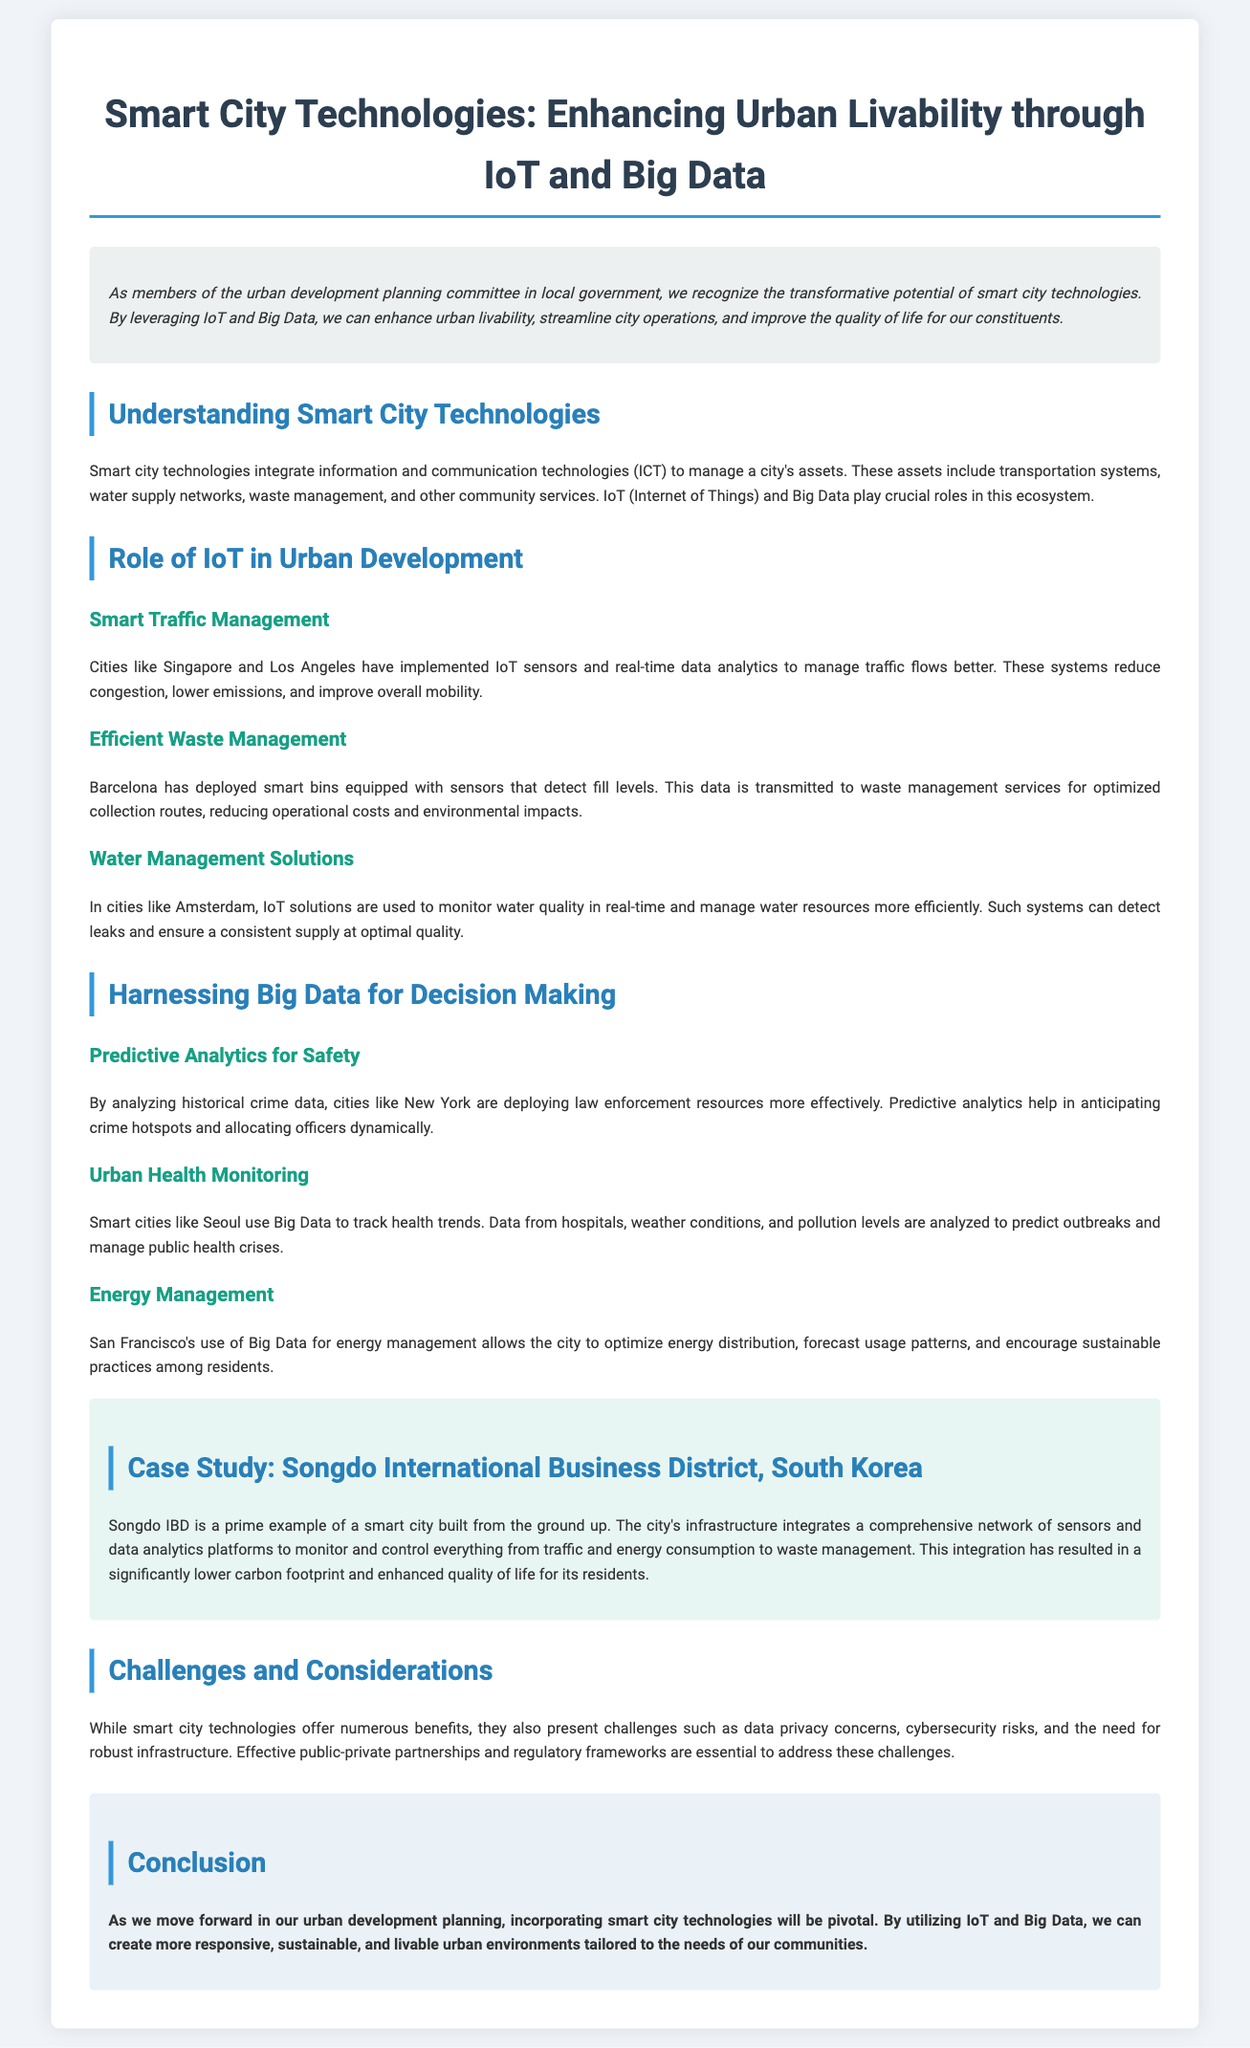What is the title of the document? The title of the document is found at the top of the rendered version.
Answer: Smart City Technologies: Enhancing Urban Livability through IoT and Big Data What is a key benefit of IoT mentioned in the document? The document outlines various benefits of IoT under different sections.
Answer: Smooth traffic management Which city has implemented smart bins for waste management? The document provides specific examples of cities deploying smart technologies for waste management.
Answer: Barcelona What type of data is analyzed for urban health monitoring in Seoul? The document mentions the types of data utilized in smart city health monitoring.
Answer: Health trends What technological aspect does Songdo International Business District integrate comprehensively? The case study describes the technological integration within this smart city.
Answer: Sensors and data analytics What challenge related to smart city technologies is discussed? The document highlights various challenges faced while implementing smart city technologies.
Answer: Data privacy How does New York use predictive analytics? The document explains the application of predictive analytics in urban safety.
Answer: Dynamically allocating officers In what environmental aspect does San Francisco optimize using Big Data? The document lists areas where cities use Big Data for improvement.
Answer: Energy distribution What foundational elements for addressing smart city challenges are mentioned? The challenges section discusses necessary elements to overcome difficulties in implementation.
Answer: Public-private partnerships 